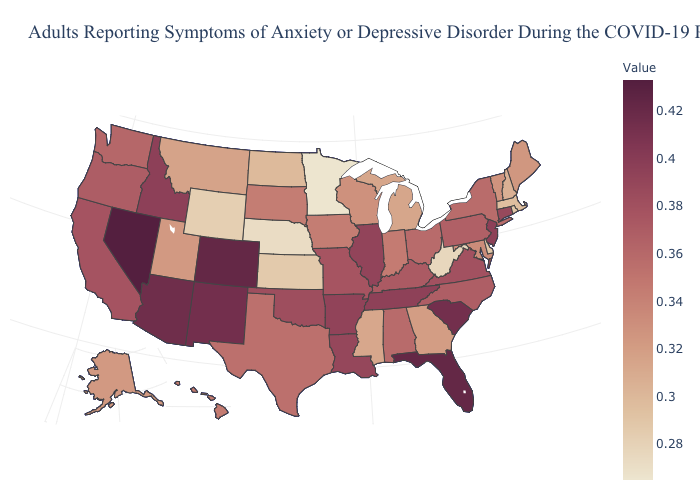Is the legend a continuous bar?
Answer briefly. Yes. Does Alaska have a lower value than West Virginia?
Give a very brief answer. No. Among the states that border Arizona , does Utah have the lowest value?
Short answer required. Yes. Which states have the highest value in the USA?
Give a very brief answer. Nevada. 